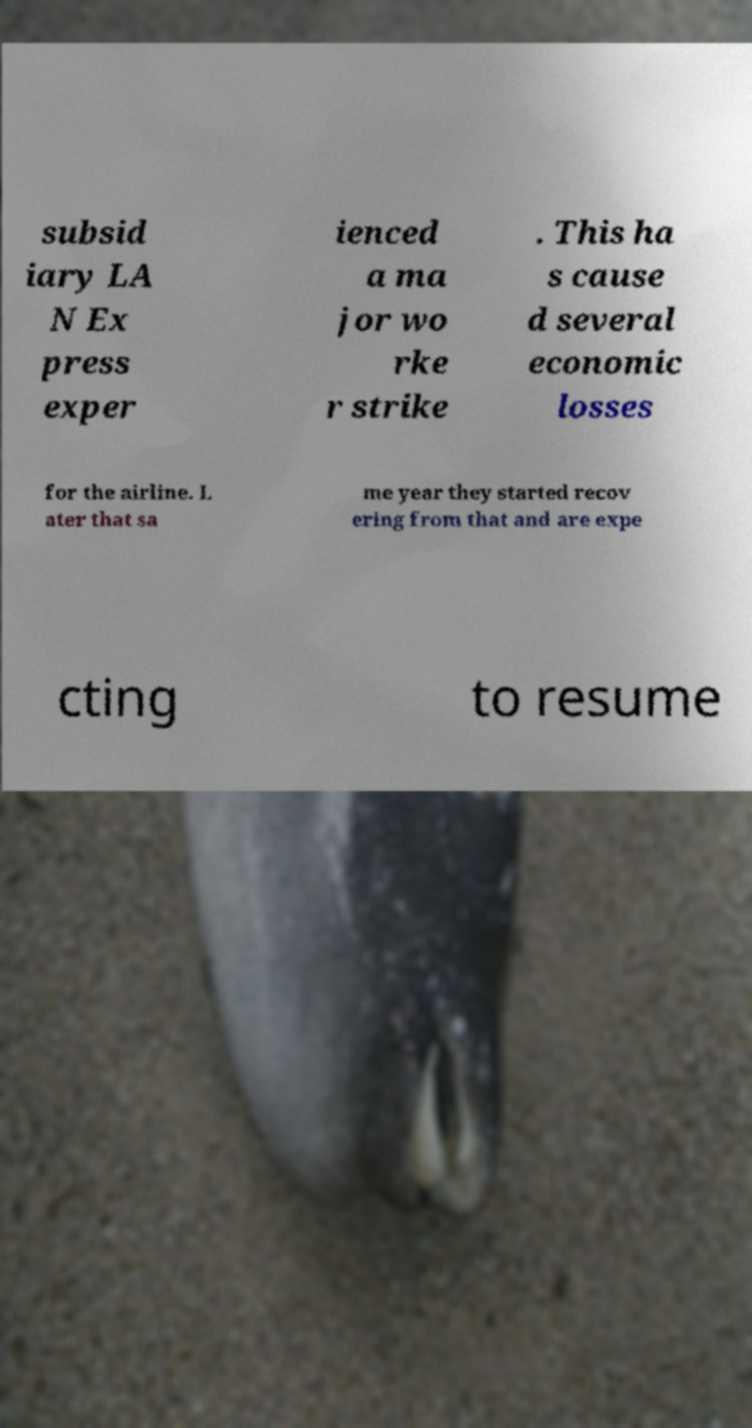Could you assist in decoding the text presented in this image and type it out clearly? subsid iary LA N Ex press exper ienced a ma jor wo rke r strike . This ha s cause d several economic losses for the airline. L ater that sa me year they started recov ering from that and are expe cting to resume 